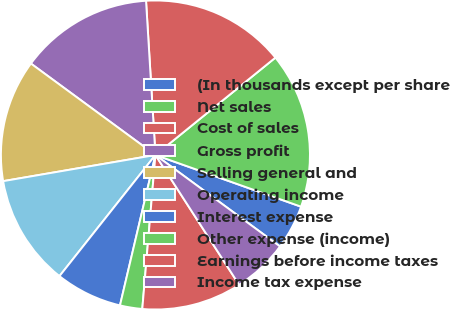Convert chart to OTSL. <chart><loc_0><loc_0><loc_500><loc_500><pie_chart><fcel>(In thousands except per share<fcel>Net sales<fcel>Cost of sales<fcel>Gross profit<fcel>Selling general and<fcel>Operating income<fcel>Interest expense<fcel>Other expense (income)<fcel>Earnings before income taxes<fcel>Income tax expense<nl><fcel>4.65%<fcel>16.28%<fcel>15.12%<fcel>13.95%<fcel>12.79%<fcel>11.63%<fcel>6.98%<fcel>2.33%<fcel>10.47%<fcel>5.81%<nl></chart> 